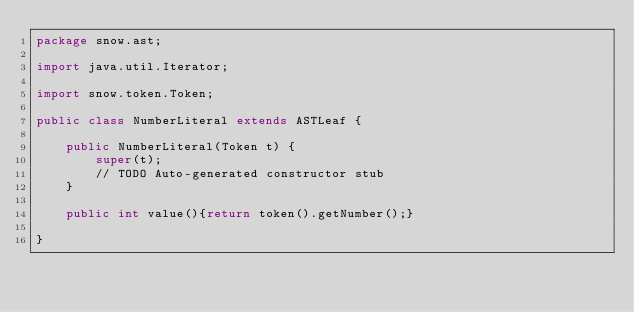Convert code to text. <code><loc_0><loc_0><loc_500><loc_500><_Java_>package snow.ast;

import java.util.Iterator;

import snow.token.Token;

public class NumberLiteral extends ASTLeaf {

	public NumberLiteral(Token t) {
		super(t);
		// TODO Auto-generated constructor stub
	}
	
	public int value(){return token().getNumber();}

}
</code> 